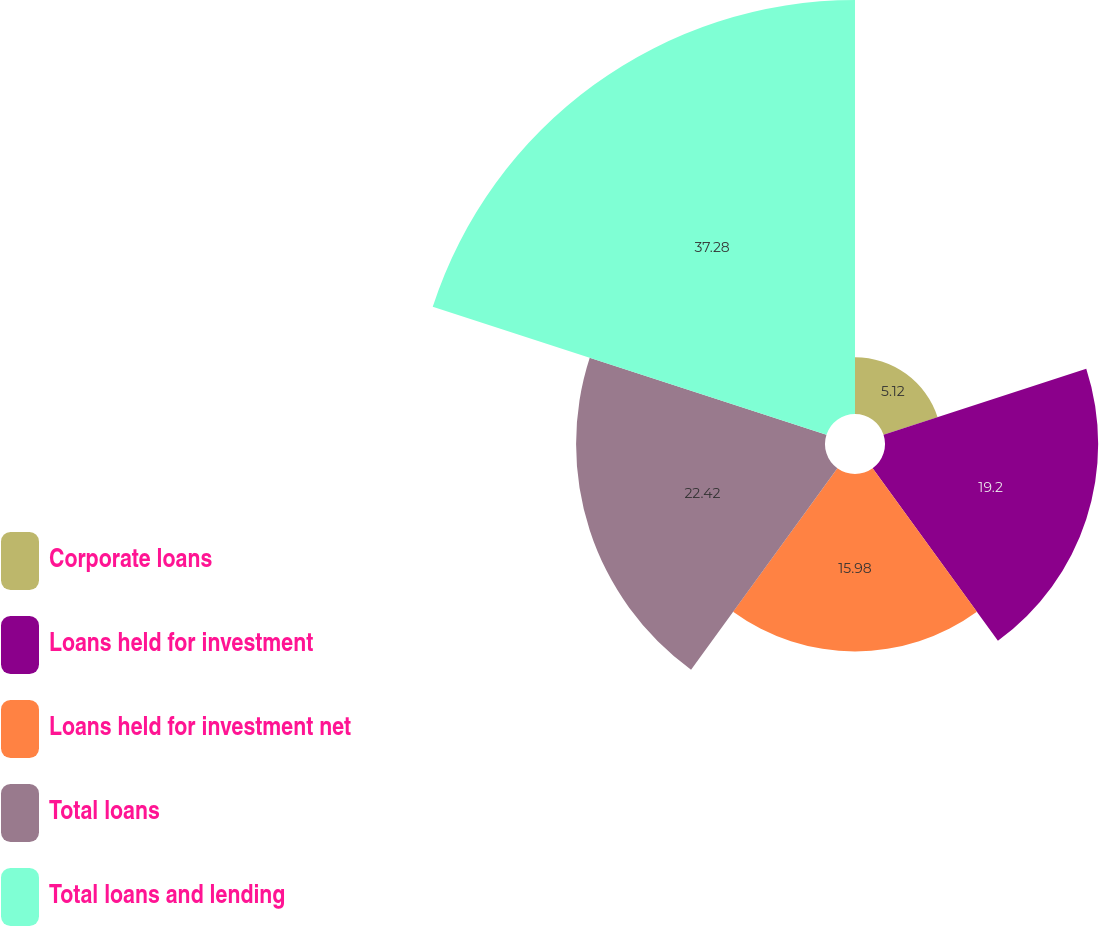<chart> <loc_0><loc_0><loc_500><loc_500><pie_chart><fcel>Corporate loans<fcel>Loans held for investment<fcel>Loans held for investment net<fcel>Total loans<fcel>Total loans and lending<nl><fcel>5.12%<fcel>19.2%<fcel>15.98%<fcel>22.42%<fcel>37.29%<nl></chart> 